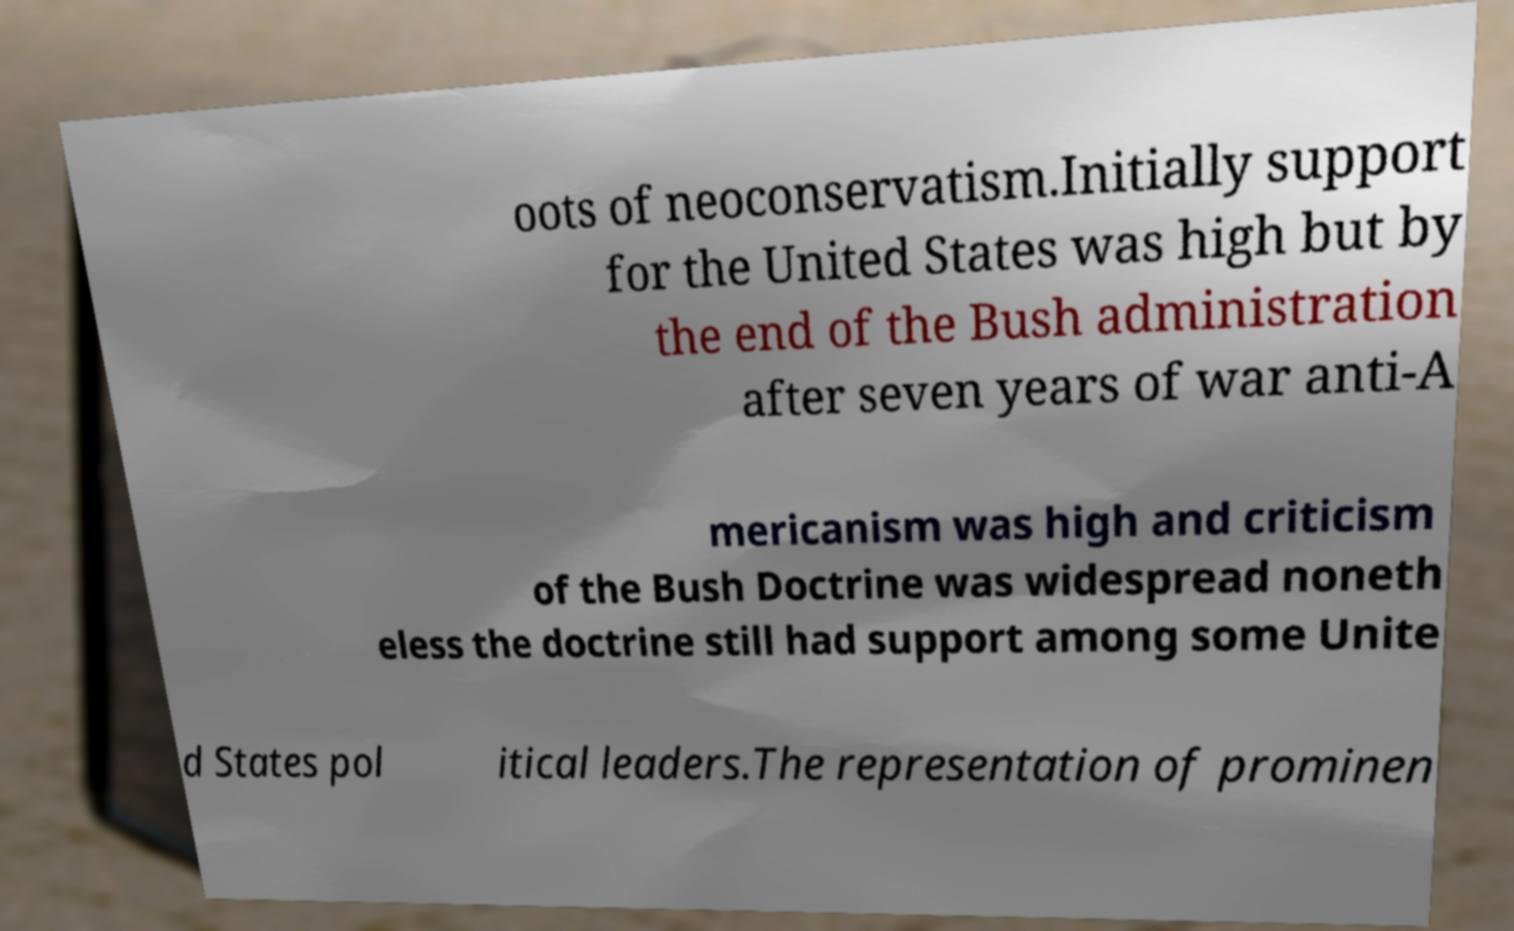I need the written content from this picture converted into text. Can you do that? oots of neoconservatism.Initially support for the United States was high but by the end of the Bush administration after seven years of war anti-A mericanism was high and criticism of the Bush Doctrine was widespread noneth eless the doctrine still had support among some Unite d States pol itical leaders.The representation of prominen 